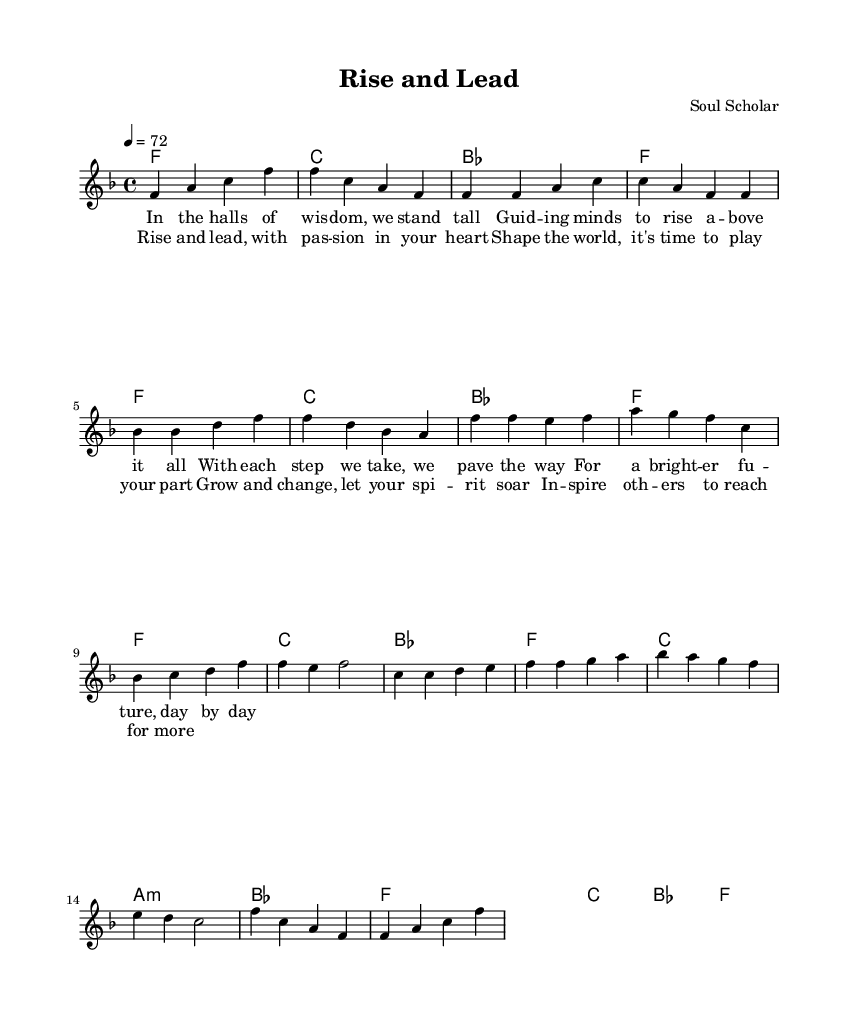What is the key signature of this music? The key signature is F major, which has one flat (B flat).
Answer: F major What is the time signature of this piece? The time signature of this piece is 4/4, indicating four beats in a measure.
Answer: 4/4 What is the tempo marking indicated? The tempo marking is 72, meaning the quarter note is played at 72 beats per minute.
Answer: 72 How many measures are in the chorus section? The chorus has four measures as can be counted in the specified section.
Answer: 4 What primary emotion does the title "Rise and Lead" suggest? The title suggests positivity and empowerment, reflecting themes of personal growth and leadership.
Answer: Empowerment What is the role of the bridge in this ballad structure? The bridge serves to provide contrast and build emotional intensity before returning to the chorus.
Answer: Contrast 